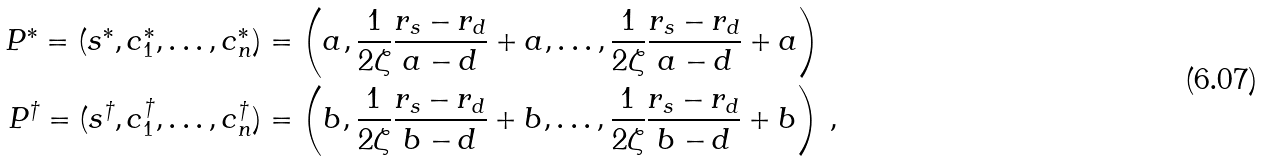<formula> <loc_0><loc_0><loc_500><loc_500>P ^ { \ast } = ( s ^ { \ast } , c _ { 1 } ^ { \ast } , \dots , c _ { n } ^ { \ast } ) & = \left ( a , \frac { 1 } { 2 \zeta } \frac { r _ { s } - r _ { d } } { a - d } + a , \dots , \frac { 1 } { 2 \zeta } \frac { r _ { s } - r _ { d } } { a - d } + a \right ) \\ P ^ { \dagger } = ( s ^ { \dagger } , c _ { 1 } ^ { \dagger } , \dots , c _ { n } ^ { \dagger } ) & = \left ( b , \frac { 1 } { 2 \zeta } \frac { r _ { s } - r _ { d } } { b - d } + b , \dots , \frac { 1 } { 2 \zeta } \frac { r _ { s } - r _ { d } } { b - d } + b \right ) \, ,</formula> 